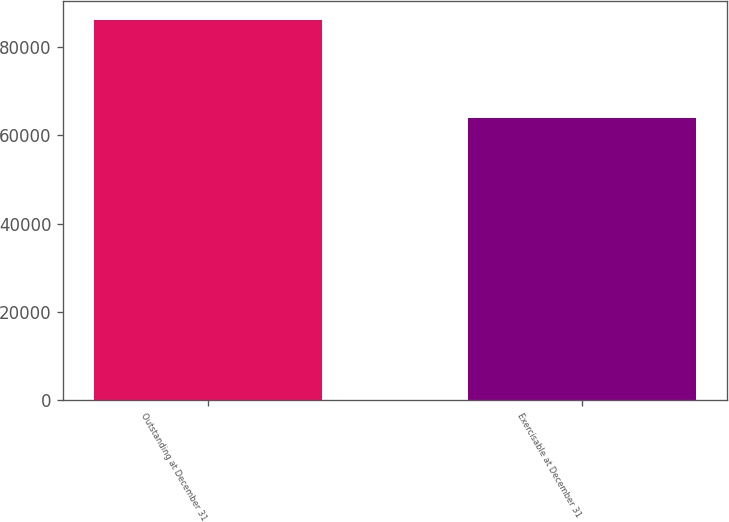Convert chart. <chart><loc_0><loc_0><loc_500><loc_500><bar_chart><fcel>Outstanding at December 31<fcel>Exercisable at December 31<nl><fcel>86319<fcel>63898.8<nl></chart> 